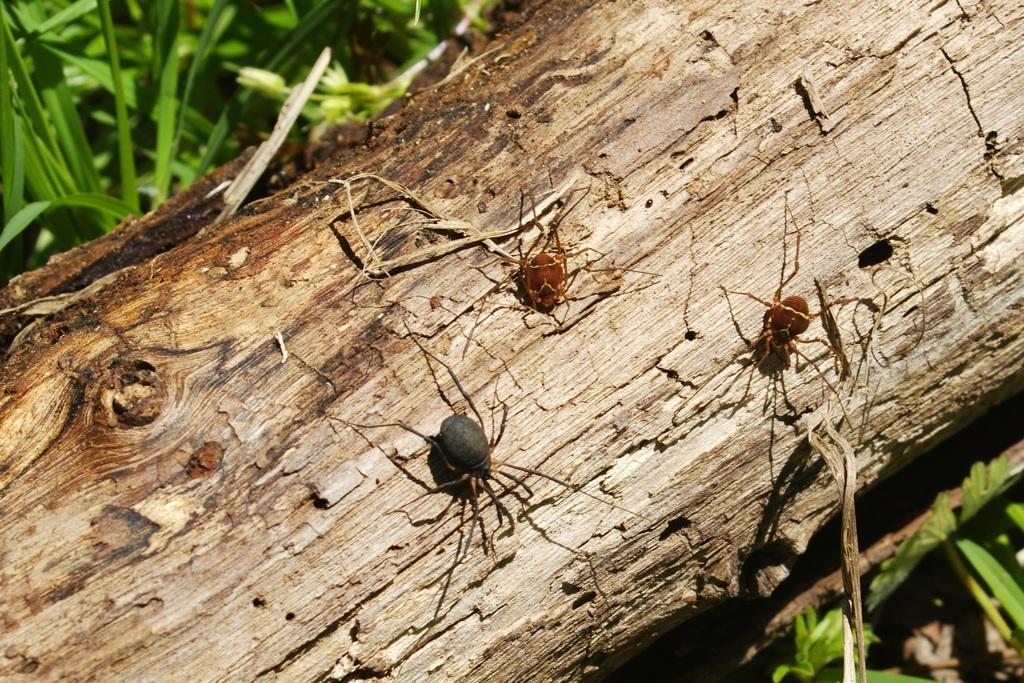In one or two sentences, can you explain what this image depicts? In this picture we can see a few insects on a wooden object. We can see some grass in the top left and in the bottom right. 